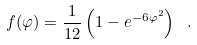Convert formula to latex. <formula><loc_0><loc_0><loc_500><loc_500>f ( \varphi ) = \frac { 1 } { 1 2 } \left ( 1 - e ^ { - 6 \varphi ^ { 2 } } \right ) \ .</formula> 